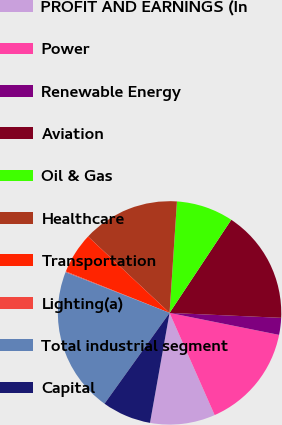Convert chart. <chart><loc_0><loc_0><loc_500><loc_500><pie_chart><fcel>PROFIT AND EARNINGS (In<fcel>Power<fcel>Renewable Energy<fcel>Aviation<fcel>Oil & Gas<fcel>Healthcare<fcel>Transportation<fcel>Lighting(a)<fcel>Total industrial segment<fcel>Capital<nl><fcel>9.42%<fcel>15.23%<fcel>2.45%<fcel>16.39%<fcel>8.26%<fcel>14.07%<fcel>5.93%<fcel>0.12%<fcel>21.04%<fcel>7.09%<nl></chart> 